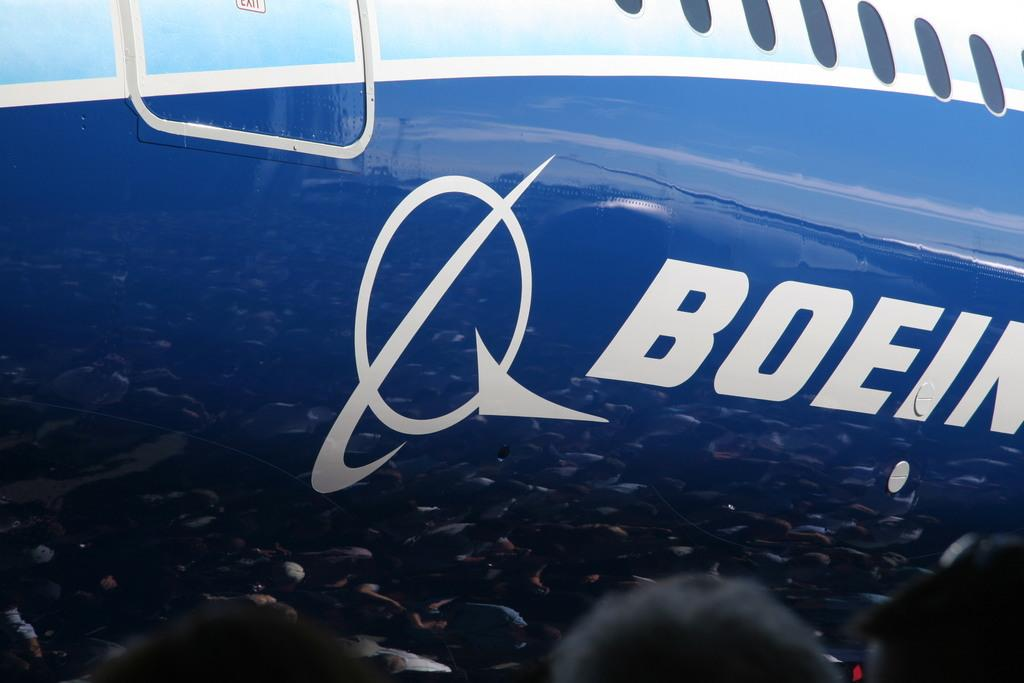<image>
Summarize the visual content of the image. A Boeing plane has a symbol with a circle and an arrow. 